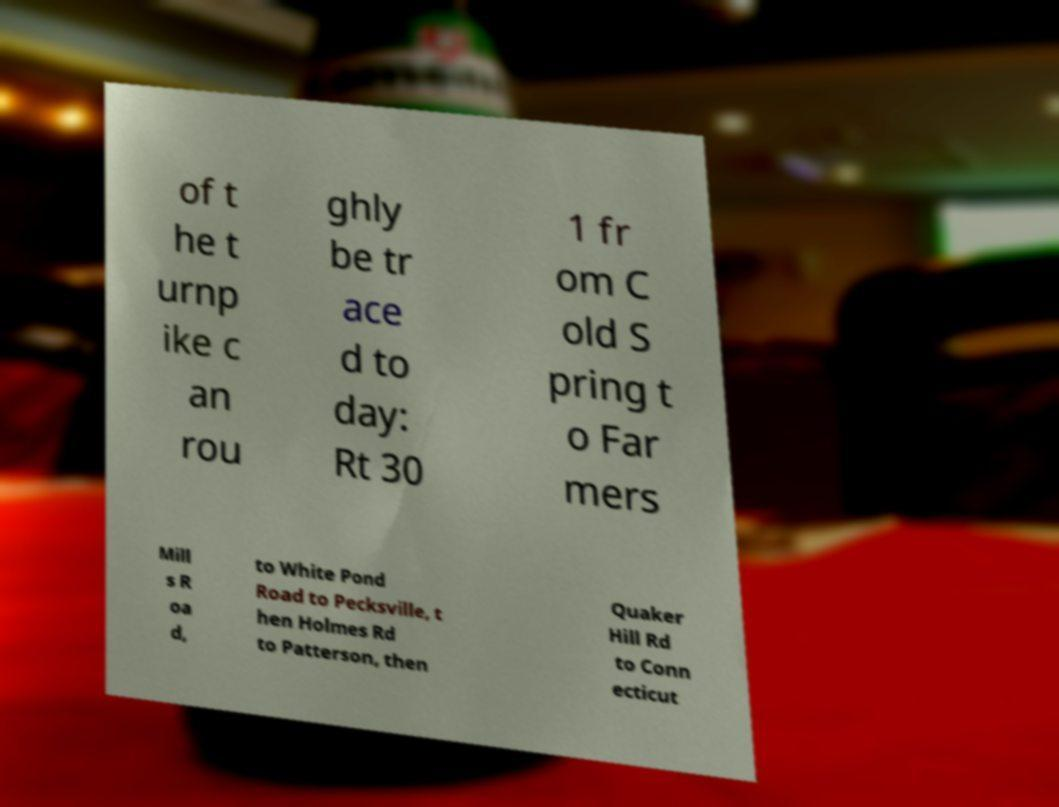Please identify and transcribe the text found in this image. of t he t urnp ike c an rou ghly be tr ace d to day: Rt 30 1 fr om C old S pring t o Far mers Mill s R oa d, to White Pond Road to Pecksville, t hen Holmes Rd to Patterson, then Quaker Hill Rd to Conn ecticut 